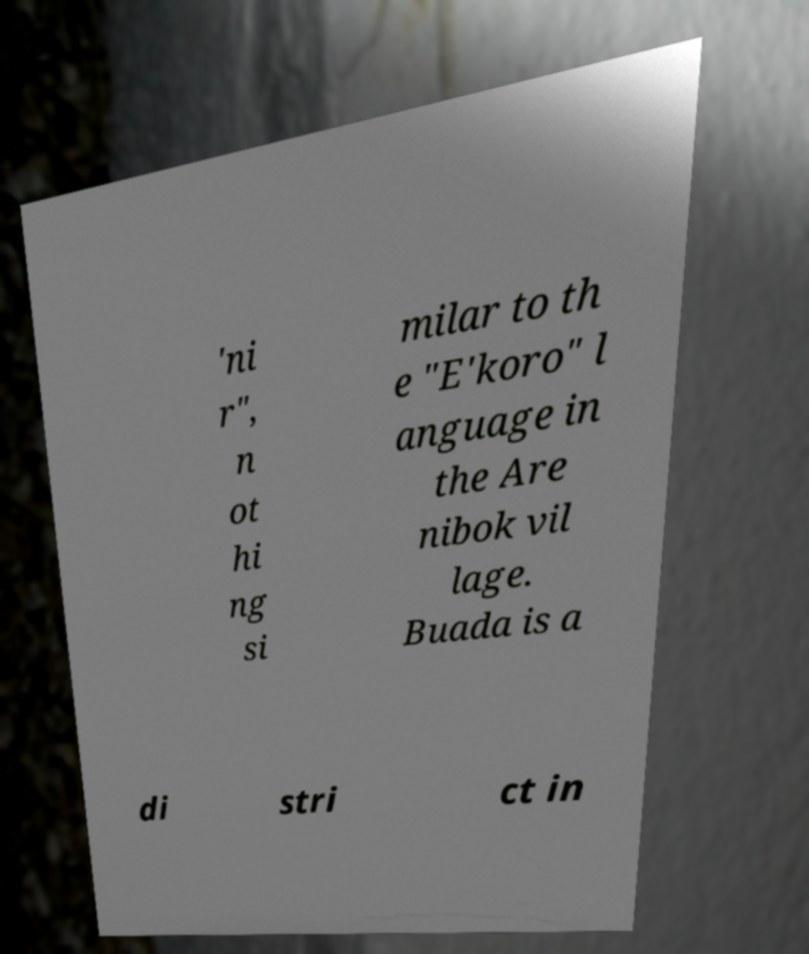Please identify and transcribe the text found in this image. 'ni r", n ot hi ng si milar to th e "E'koro" l anguage in the Are nibok vil lage. Buada is a di stri ct in 